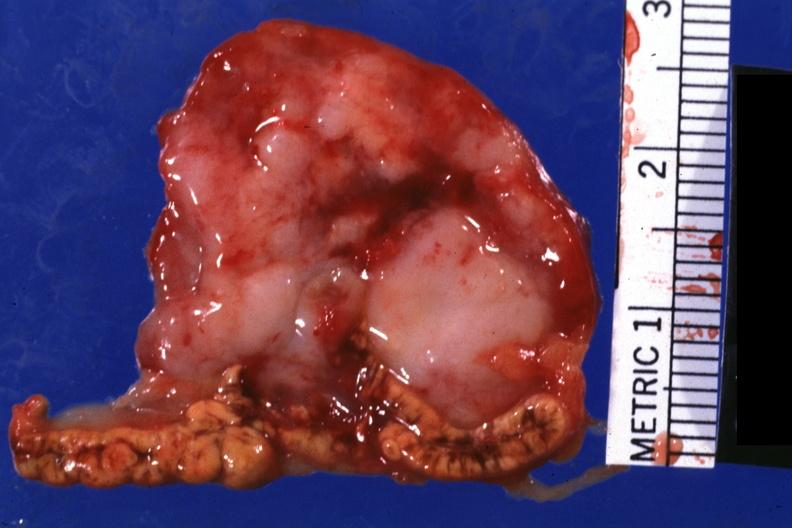does lower chest and abdomen anterior show close-up very good photo?
Answer the question using a single word or phrase. No 